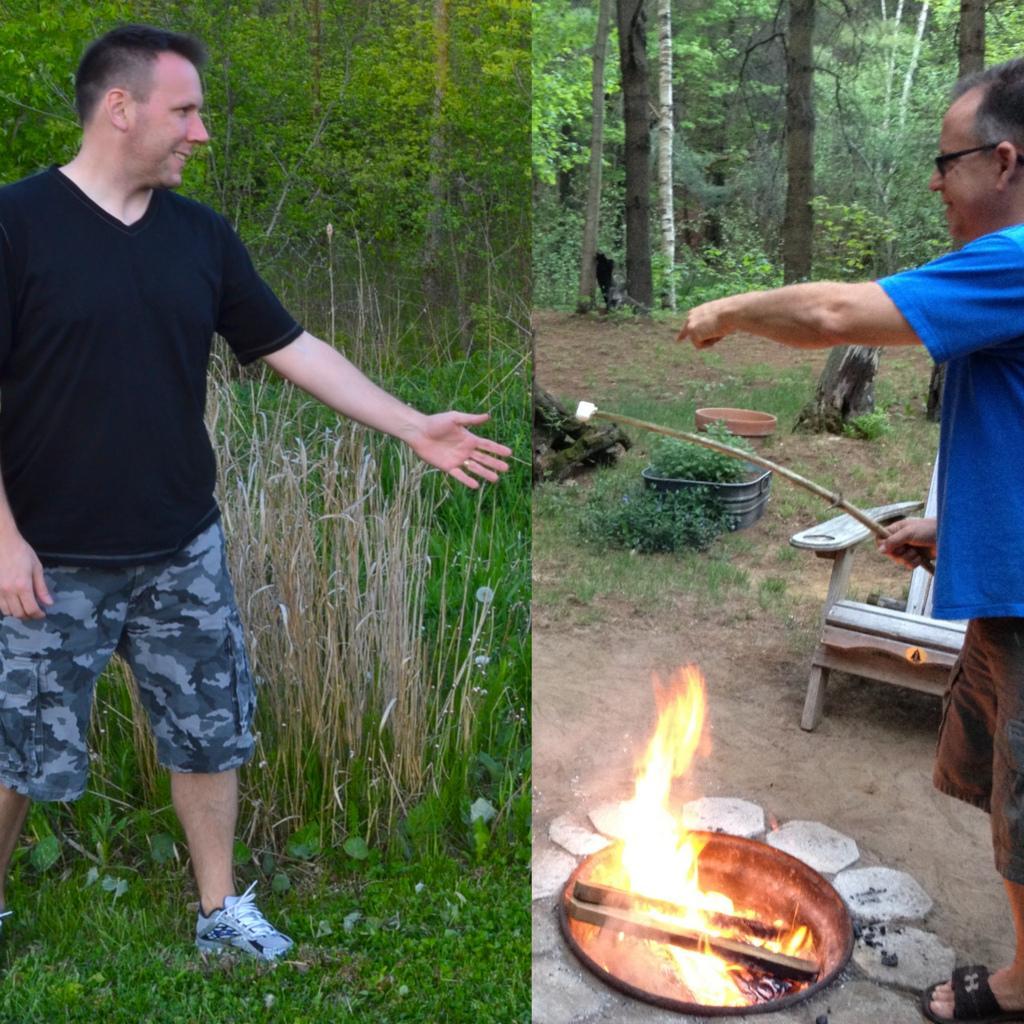Please provide a concise description of this image. This picture is a collage. On the left there is a person standing. In the picture there are trees, grass and plants. On the right there are fire camp, person, chair and plants. In the background there are trees. 